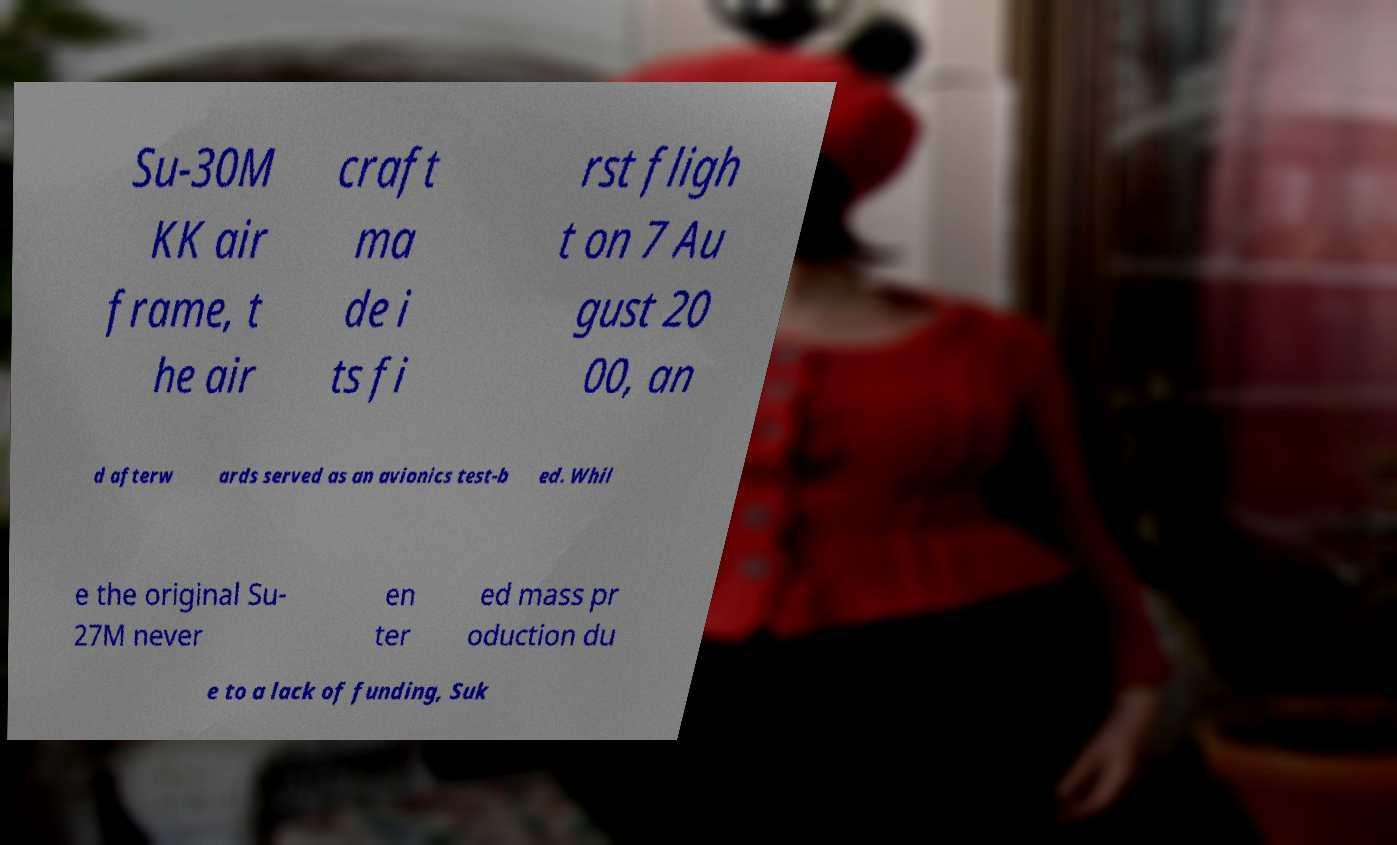Can you read and provide the text displayed in the image?This photo seems to have some interesting text. Can you extract and type it out for me? Su-30M KK air frame, t he air craft ma de i ts fi rst fligh t on 7 Au gust 20 00, an d afterw ards served as an avionics test-b ed. Whil e the original Su- 27M never en ter ed mass pr oduction du e to a lack of funding, Suk 